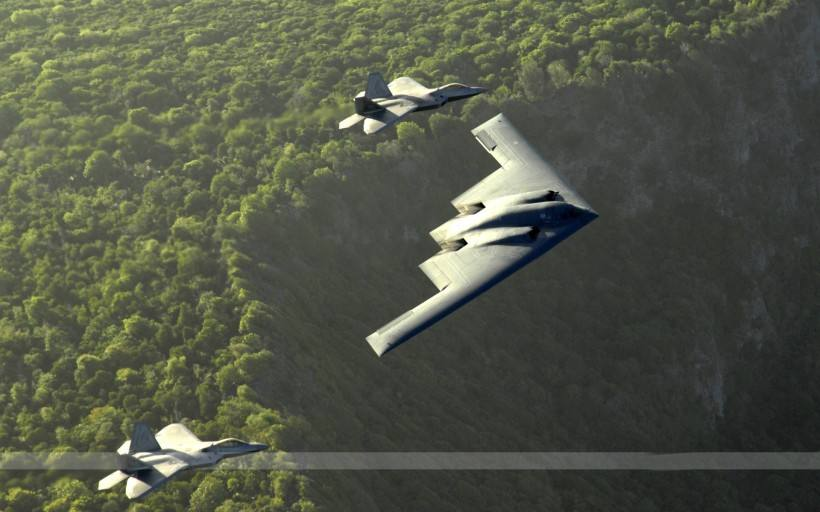Can you describe the manoeuvre that the aeroplanes are performing? The aeroplanes are engaged in a high-precision flight formation, with the lead plane being flanked closely on either side. This formation requires skillful coordination and is often seen in military or air show demonstrations. 